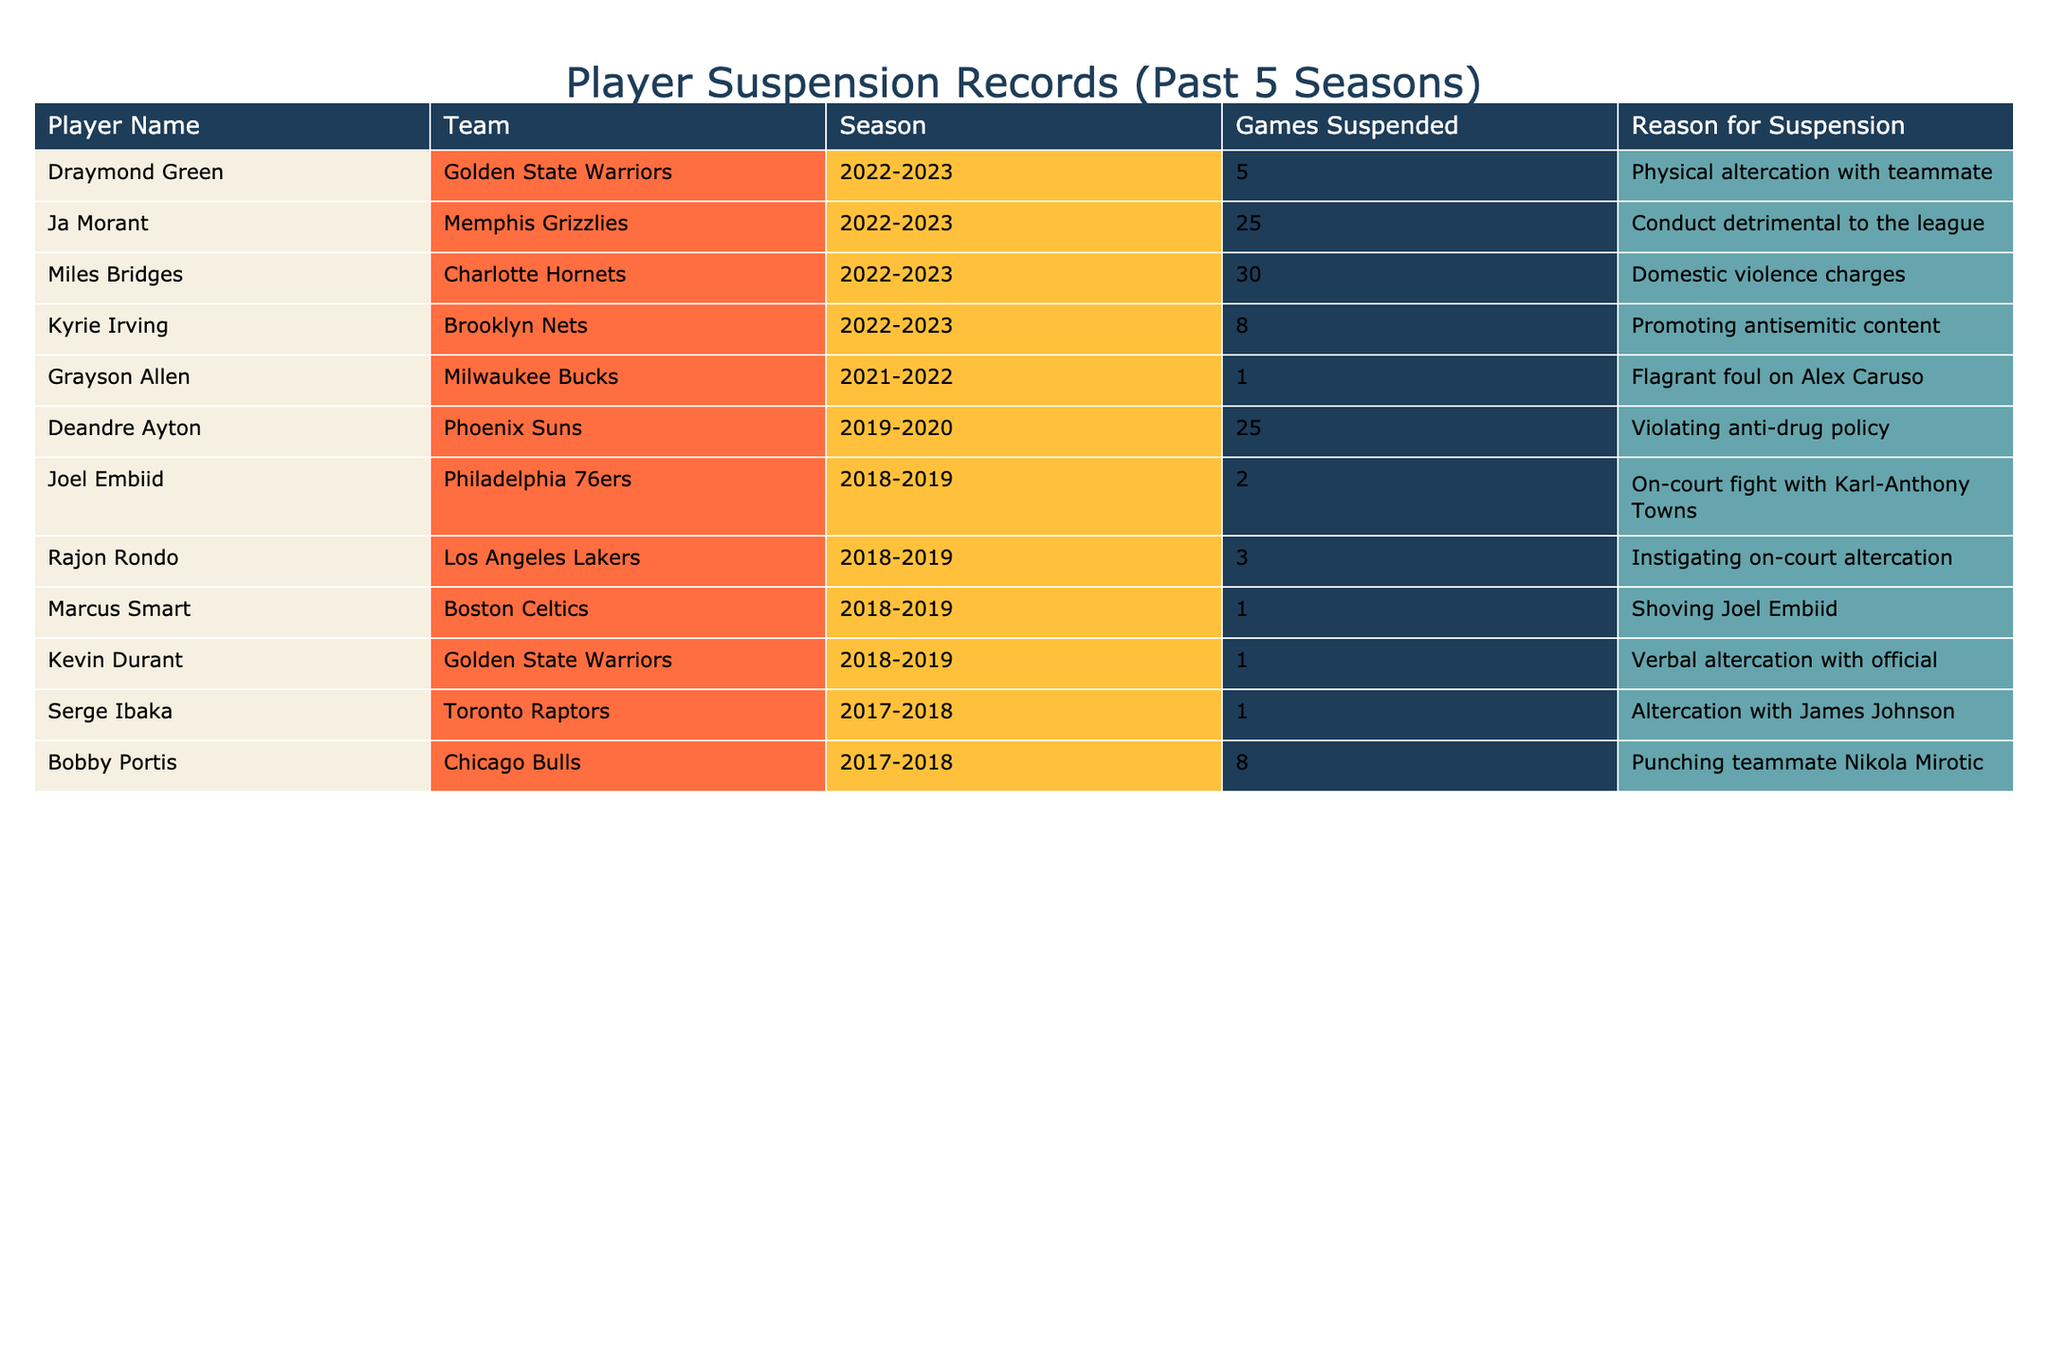What is the total number of games suspended for Miles Bridges? The table lists Miles Bridges with 30 games suspended due to domestic violence charges. Therefore, the answer is directly found in the duty records.
Answer: 30 How many players were suspended for conduct detrimental to the league? The table shows that Ja Morant was suspended for conduct detrimental to the league, indicating that he is the only player with this reason within the records provided.
Answer: 1 Which player had the highest number of games suspended in the 2022-2023 season? In the 2022-2023 season, Miles Bridges had the highest suspension at 30 games. Comparing this figure to the others in the same season leads to this conclusion.
Answer: Miles Bridges What is the average number of games suspended across all players in the table? To find the average, we sum all games suspended (5 + 25 + 30 + 8 + 1 + 25 + 2 + 3 + 1 + 1 + 1 + 8 = 109) and divide by the number of players (12). So, the average is 109/12 = 9.08, rounded to two decimal places.
Answer: 9.08 Were there any players suspended for on-court altercations? Yes, both Draymond Green and Rajon Rondo were suspended for physical altercation and instigating on-court altercation, respectively. This is confirmed by reviewing the reasons for suspension given in the table.
Answer: Yes How many players were suspended for a total greater than 10 games? Upon examining the table, players with suspensions greater than 10 games include Ja Morant (25), Miles Bridges (30), and Deandre Ayton (25). Thus, there are a total of three players fitting this criterion.
Answer: 3 Which team had the player with the least number of games suspended? The Milwaukee Bucks had Grayson Allen, who was suspended for only 1 game. When reviewing the records, no other player has fewer games suspended.
Answer: Milwaukee Bucks What was the reason for Kevin Durant's suspension? The table specifies that Kevin Durant was suspended for a verbal altercation with an official. This is clearly listed under the reasons for suspension in the table.
Answer: Verbal altercation with official How does the total number of games suspended by Draymond Green compare to the total by Kyrie Irving? Draymond Green was suspended for 5 games, while Kyrie Irving was suspended for 8 games. Comparing these two numbers reveals that Kyrie Irving had 3 more games suspended than Draymond Green.
Answer: Kyrie Irving had 3 more games suspended What proportion of the suspensions were caused by physical altercations? The total number of suspensions due to physical altercations is 3 (Draymond Green, Rajon Rondo, and Serge Ibaka) out of a total of 12 players. Thus, the proportion is 3/12, which simplifies to 1/4, or 25%.
Answer: 25% 